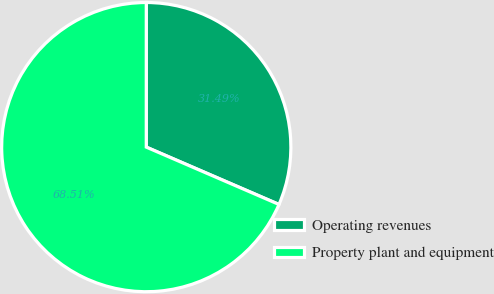Convert chart to OTSL. <chart><loc_0><loc_0><loc_500><loc_500><pie_chart><fcel>Operating revenues<fcel>Property plant and equipment<nl><fcel>31.49%<fcel>68.51%<nl></chart> 